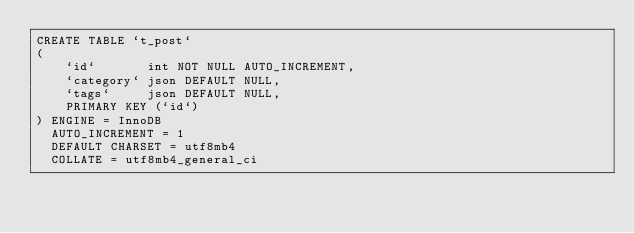Convert code to text. <code><loc_0><loc_0><loc_500><loc_500><_SQL_>CREATE TABLE `t_post`
(
    `id`       int NOT NULL AUTO_INCREMENT,
    `category` json DEFAULT NULL,
    `tags`     json DEFAULT NULL,
    PRIMARY KEY (`id`)
) ENGINE = InnoDB
  AUTO_INCREMENT = 1
  DEFAULT CHARSET = utf8mb4
  COLLATE = utf8mb4_general_ci
</code> 